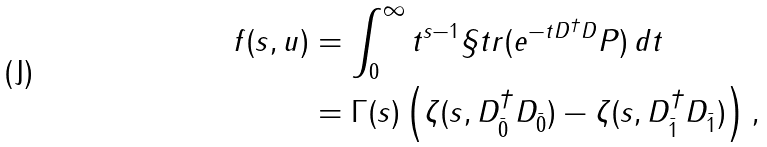<formula> <loc_0><loc_0><loc_500><loc_500>f ( s , u ) & = \int _ { 0 } ^ { \infty } t ^ { s - 1 } \S t r ( e ^ { - t D ^ { \dagger } D } P ) \, d t \\ & = \Gamma ( s ) \left ( \zeta ( s , D _ { \bar { 0 } } ^ { \dagger } D _ { \bar { 0 } } ) - \zeta ( s , D _ { \bar { 1 } } ^ { \dagger } D _ { \bar { 1 } } ) \right ) ,</formula> 